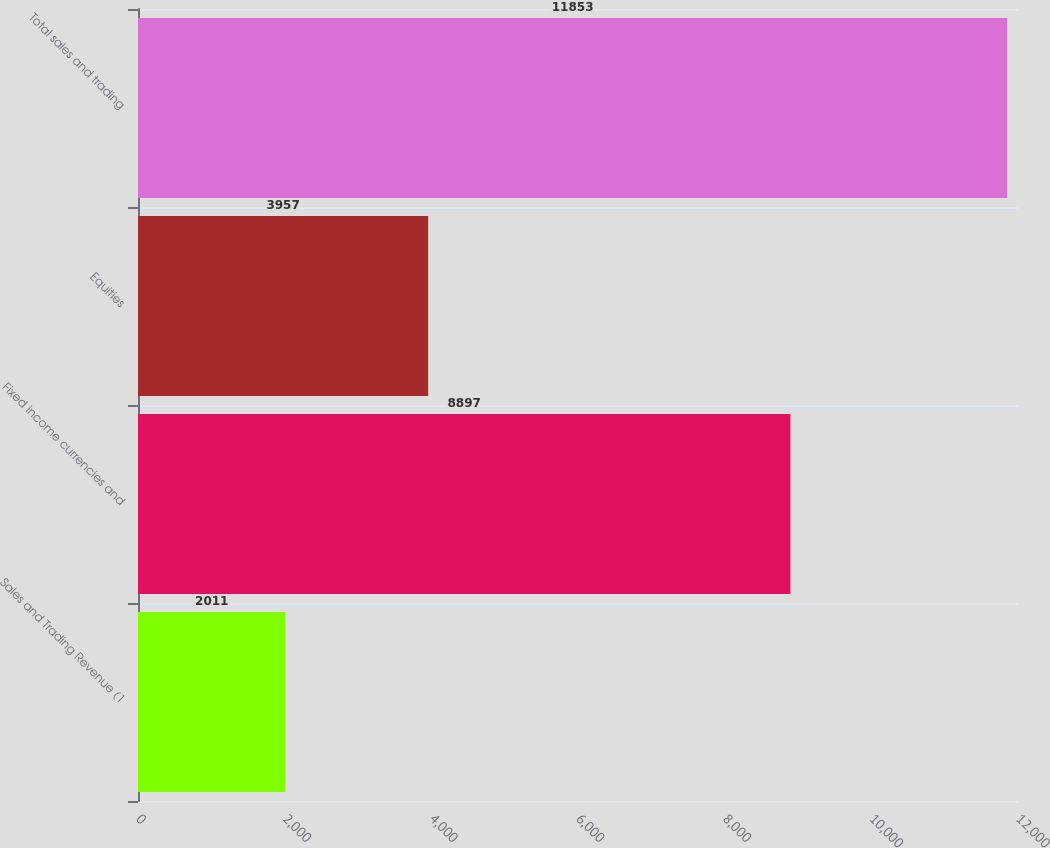<chart> <loc_0><loc_0><loc_500><loc_500><bar_chart><fcel>Sales and Trading Revenue (1<fcel>Fixed income currencies and<fcel>Equities<fcel>Total sales and trading<nl><fcel>2011<fcel>8897<fcel>3957<fcel>11853<nl></chart> 